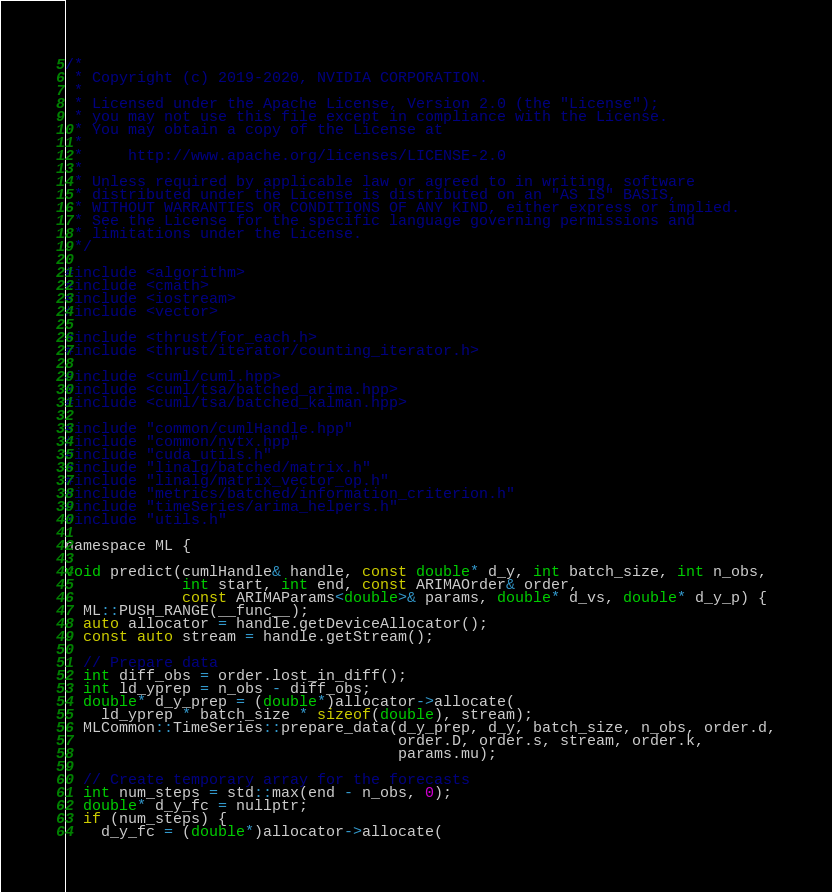<code> <loc_0><loc_0><loc_500><loc_500><_Cuda_>/*
 * Copyright (c) 2019-2020, NVIDIA CORPORATION.
 *
 * Licensed under the Apache License, Version 2.0 (the "License");
 * you may not use this file except in compliance with the License.
 * You may obtain a copy of the License at
 *
 *     http://www.apache.org/licenses/LICENSE-2.0
 *
 * Unless required by applicable law or agreed to in writing, software
 * distributed under the License is distributed on an "AS IS" BASIS,
 * WITHOUT WARRANTIES OR CONDITIONS OF ANY KIND, either express or implied.
 * See the License for the specific language governing permissions and
 * limitations under the License.
 */

#include <algorithm>
#include <cmath>
#include <iostream>
#include <vector>

#include <thrust/for_each.h>
#include <thrust/iterator/counting_iterator.h>

#include <cuml/cuml.hpp>
#include <cuml/tsa/batched_arima.hpp>
#include <cuml/tsa/batched_kalman.hpp>

#include "common/cumlHandle.hpp"
#include "common/nvtx.hpp"
#include "cuda_utils.h"
#include "linalg/batched/matrix.h"
#include "linalg/matrix_vector_op.h"
#include "metrics/batched/information_criterion.h"
#include "timeSeries/arima_helpers.h"
#include "utils.h"

namespace ML {

void predict(cumlHandle& handle, const double* d_y, int batch_size, int n_obs,
             int start, int end, const ARIMAOrder& order,
             const ARIMAParams<double>& params, double* d_vs, double* d_y_p) {
  ML::PUSH_RANGE(__func__);
  auto allocator = handle.getDeviceAllocator();
  const auto stream = handle.getStream();

  // Prepare data
  int diff_obs = order.lost_in_diff();
  int ld_yprep = n_obs - diff_obs;
  double* d_y_prep = (double*)allocator->allocate(
    ld_yprep * batch_size * sizeof(double), stream);
  MLCommon::TimeSeries::prepare_data(d_y_prep, d_y, batch_size, n_obs, order.d,
                                     order.D, order.s, stream, order.k,
                                     params.mu);

  // Create temporary array for the forecasts
  int num_steps = std::max(end - n_obs, 0);
  double* d_y_fc = nullptr;
  if (num_steps) {
    d_y_fc = (double*)allocator->allocate(</code> 